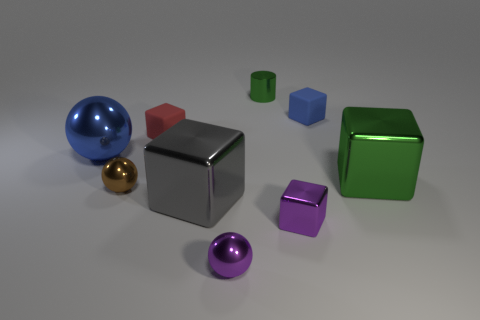What sizes are the cubes compared to each other? Observing the cubes in the image, we have a silver cube which is the largest, squarely in the center. Then there's a red cube and a green cube that are smaller and similar in size. Lastly, the purple cube is the smallest among them, adding to a sense of depth and perspective in the arrangement. 